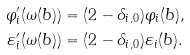<formula> <loc_0><loc_0><loc_500><loc_500>\varphi _ { i } ^ { \prime } ( \omega ( b ) ) & = ( 2 - \delta _ { i , 0 } ) \varphi _ { i } ( b ) , \\ \varepsilon _ { i } ^ { \prime } ( \omega ( b ) ) & = ( 2 - \delta _ { i , 0 } ) \varepsilon _ { i } ( b ) .</formula> 